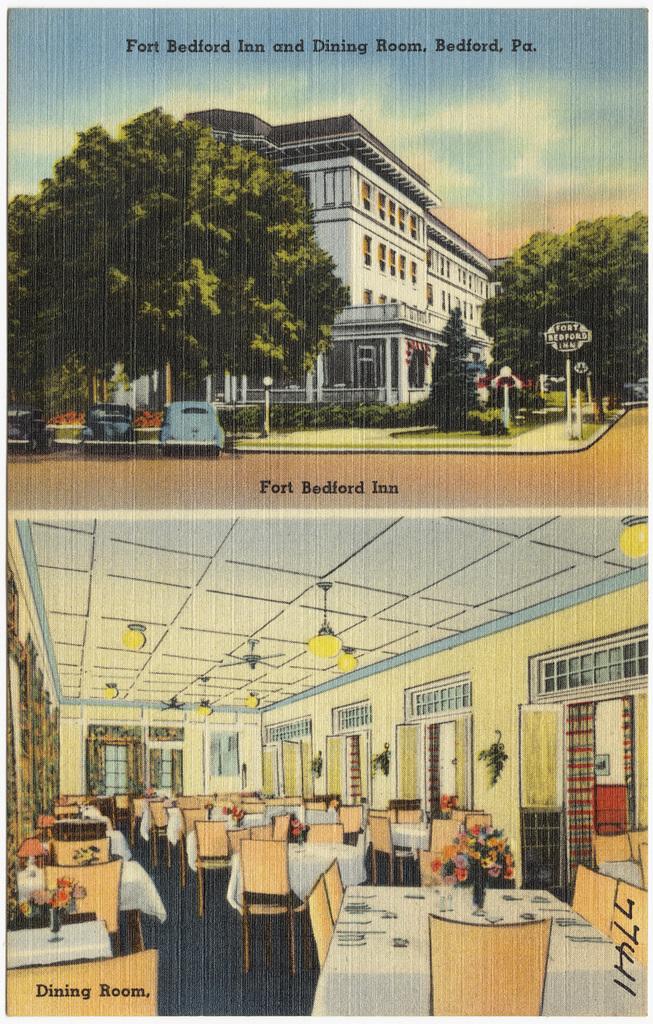What is the name of the inn?
Make the answer very short. Fort bedford. Which room is on the bottom?
Make the answer very short. Dining room. 